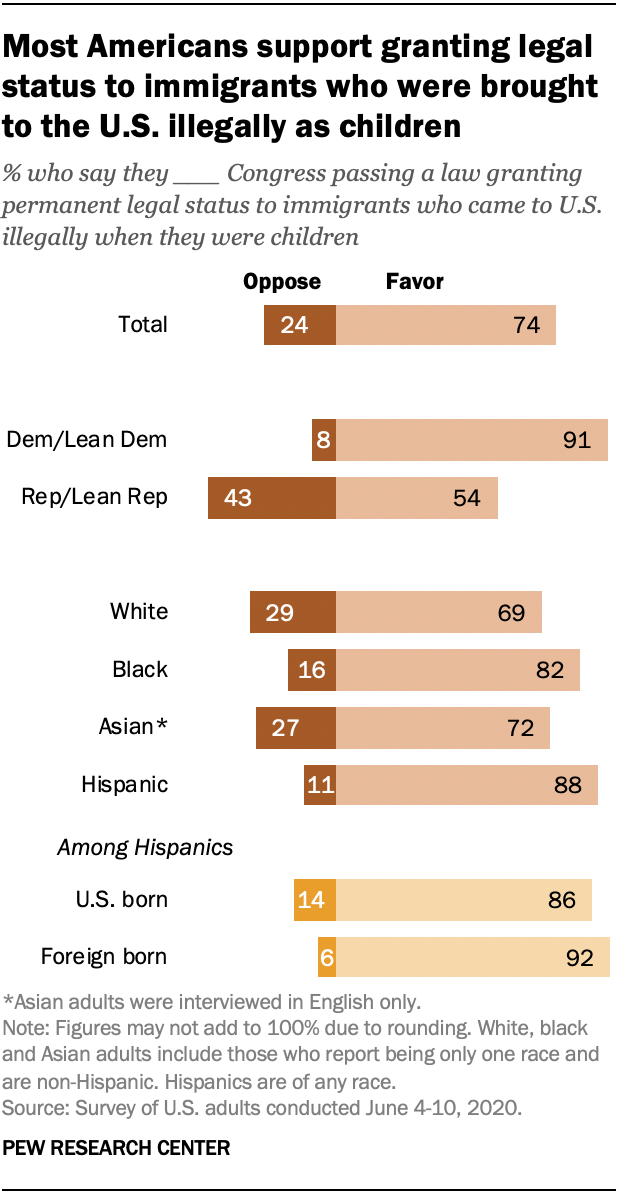Identify some key points in this picture. The sum of the percentages of those who oppose and favor a particular issue in Asia is 0.99. According to the data, 82% of Black individuals surveyed said that they favor Congress passing a law granting permanent legal status to immigrants who came to the United States illegally when they were children. 